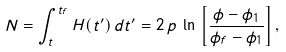Convert formula to latex. <formula><loc_0><loc_0><loc_500><loc_500>N = \int _ { t } ^ { t _ { f } } H ( t ^ { \prime } ) \, d t ^ { \prime } = 2 \, p \, \ln \, \left [ \frac { \phi - \phi _ { 1 } } { \phi _ { f } - \phi _ { 1 } } \right ] ,</formula> 